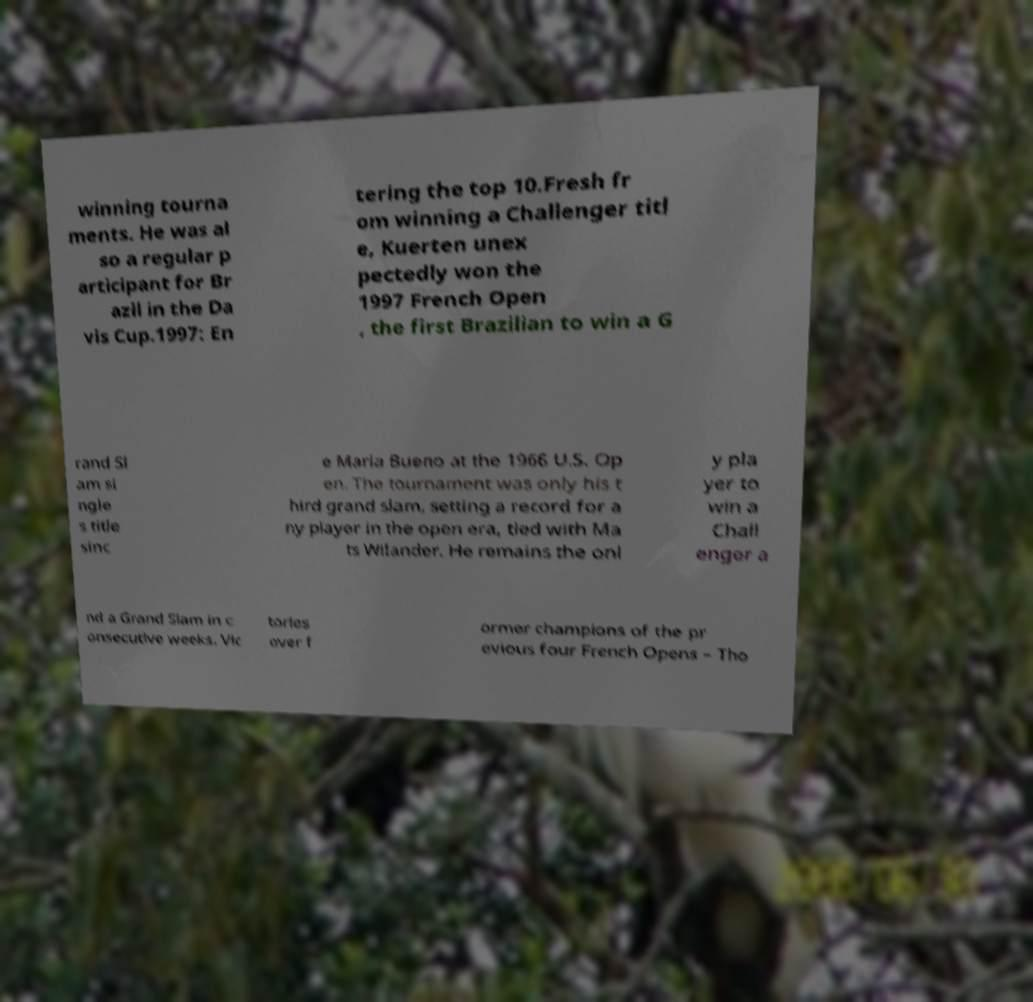For documentation purposes, I need the text within this image transcribed. Could you provide that? winning tourna ments. He was al so a regular p articipant for Br azil in the Da vis Cup.1997: En tering the top 10.Fresh fr om winning a Challenger titl e, Kuerten unex pectedly won the 1997 French Open , the first Brazilian to win a G rand Sl am si ngle s title sinc e Maria Bueno at the 1966 U.S. Op en. The tournament was only his t hird grand slam, setting a record for a ny player in the open era, tied with Ma ts Wilander. He remains the onl y pla yer to win a Chall enger a nd a Grand Slam in c onsecutive weeks. Vic tories over f ormer champions of the pr evious four French Opens – Tho 